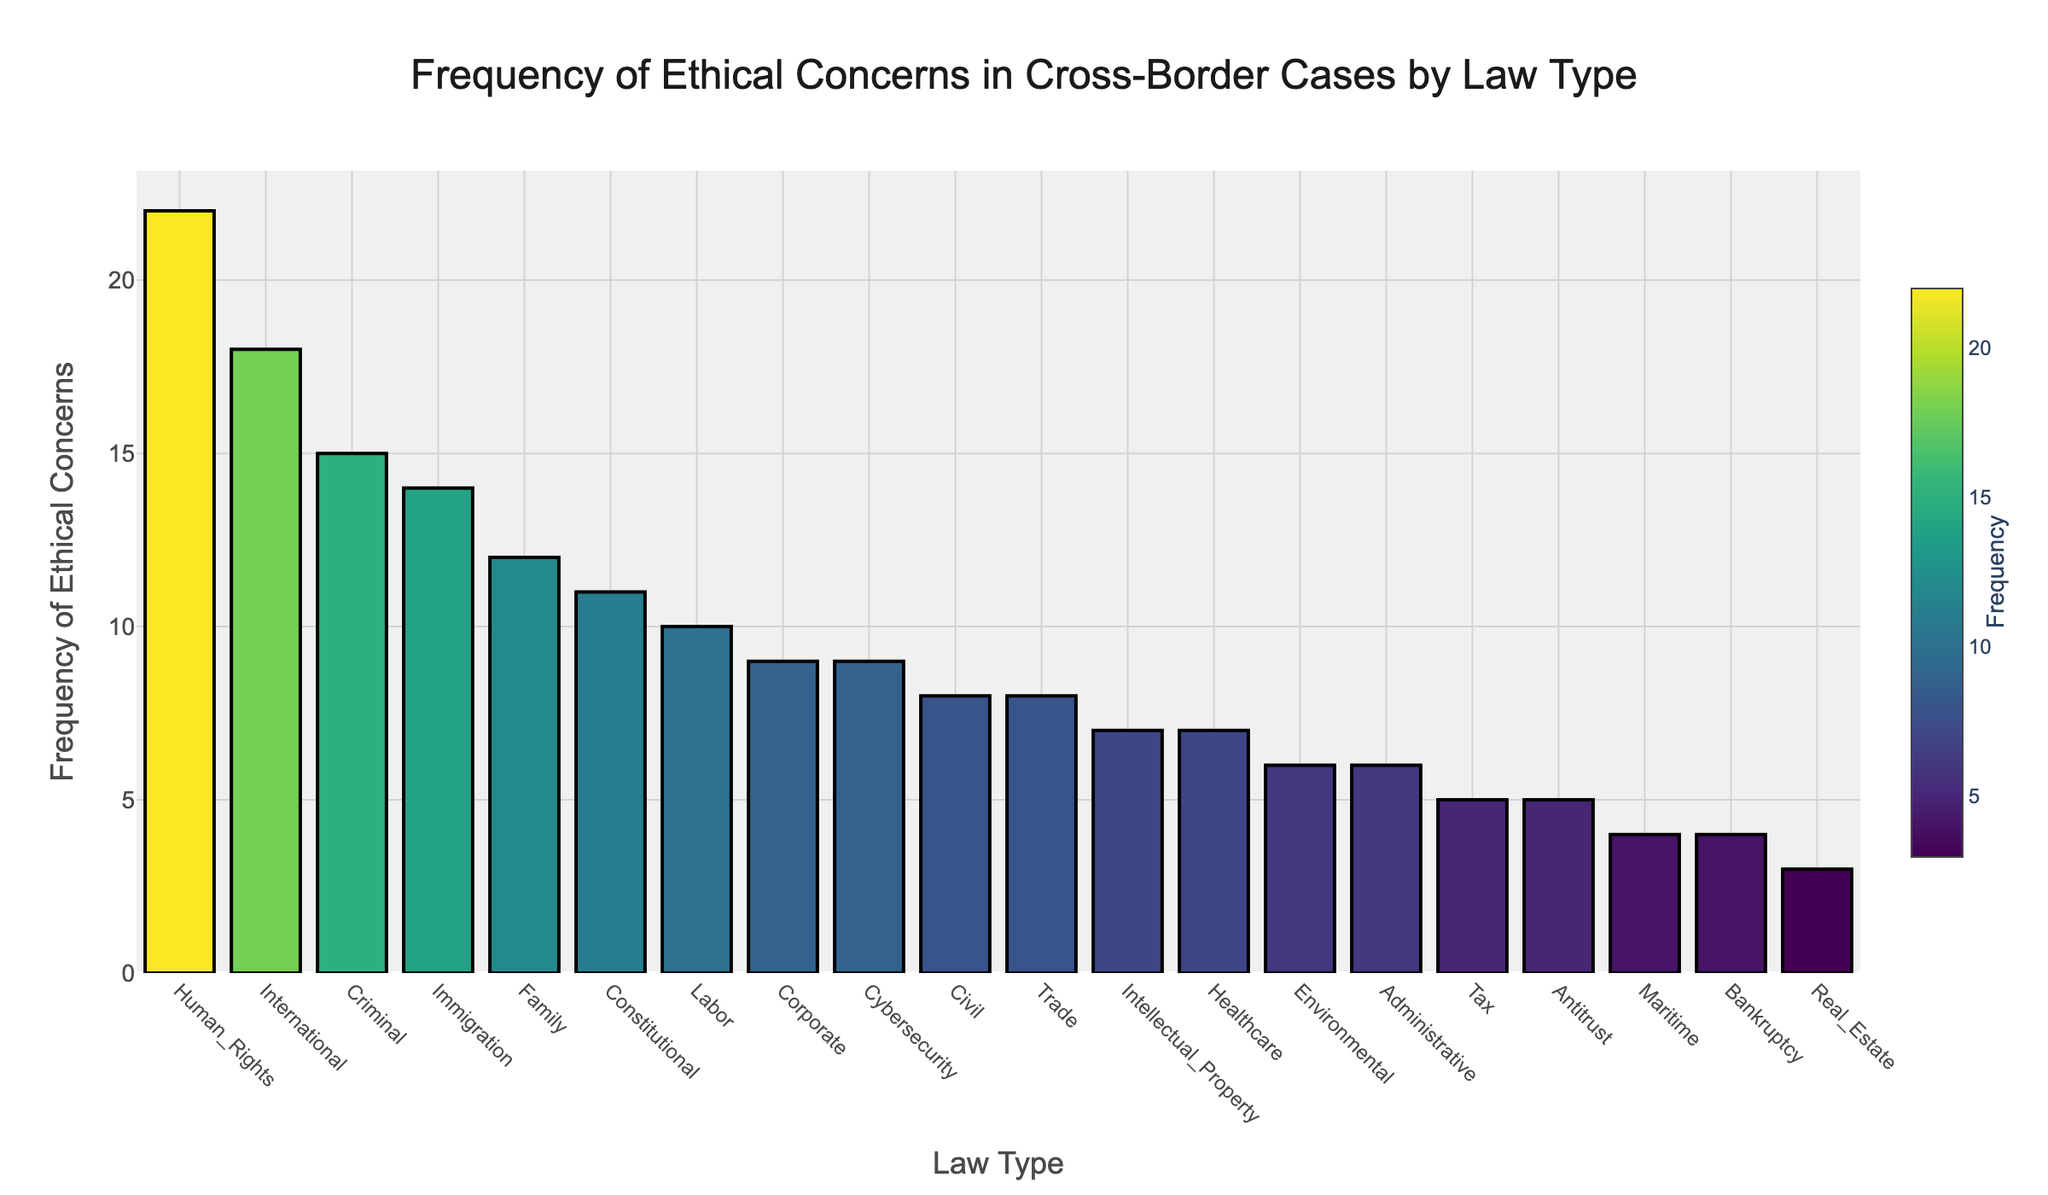What law type has the highest frequency of ethical concerns? The bar with the highest value shows that Human Rights has the highest frequency.
Answer: Human Rights What is the frequency of ethical concerns for Environmental law? Locate the Environmental bar and observe its height.
Answer: 6 Which law types have a frequency of 8 ethical concerns? Identify the bars that reach the value of 8 on the y-axis.
Answer: Civil and Trade How many law types have a frequency greater than 10? Count the bars that extend above the y-axis value of 10.
Answer: 6 What is the difference in frequency between Human Rights and Tax law? Subtract the height of the Tax bar from the height of the Human Rights bar.
Answer: 17 Which law type shows a higher frequency of ethical concerns, Family or Immigration? Compare the heights of the Family and Immigration bars.
Answer: Family What is the average frequency of ethical concerns for the top three law types with the highest frequencies? Add the frequencies of the top three law types and divide by three. (22 + 18 + 15) / 3 = 18.33
Answer: 18.33 Is the frequency of ethical concerns in Corporate law higher or lower than in Labor law? Compare the height of the Corporate bar to the Labor bar.
Answer: Lower What is the total frequency of ethical concerns for Criminal, Civil, and Family law types combined? Sum the values of the corresponding bars. 15 + 8 + 12 = 35
Answer: 35 What law type has the lowest frequency of ethical concerns? Find the bar that is the shortest in height.
Answer: Real Estate 